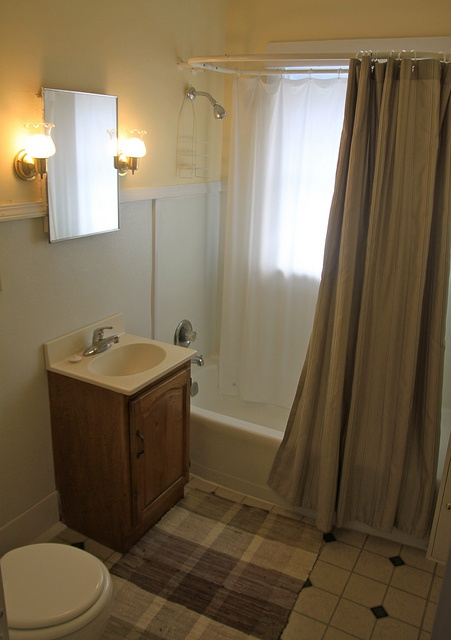Describe the objects in this image and their specific colors. I can see toilet in olive, gray, and black tones and sink in olive, tan, and gray tones in this image. 